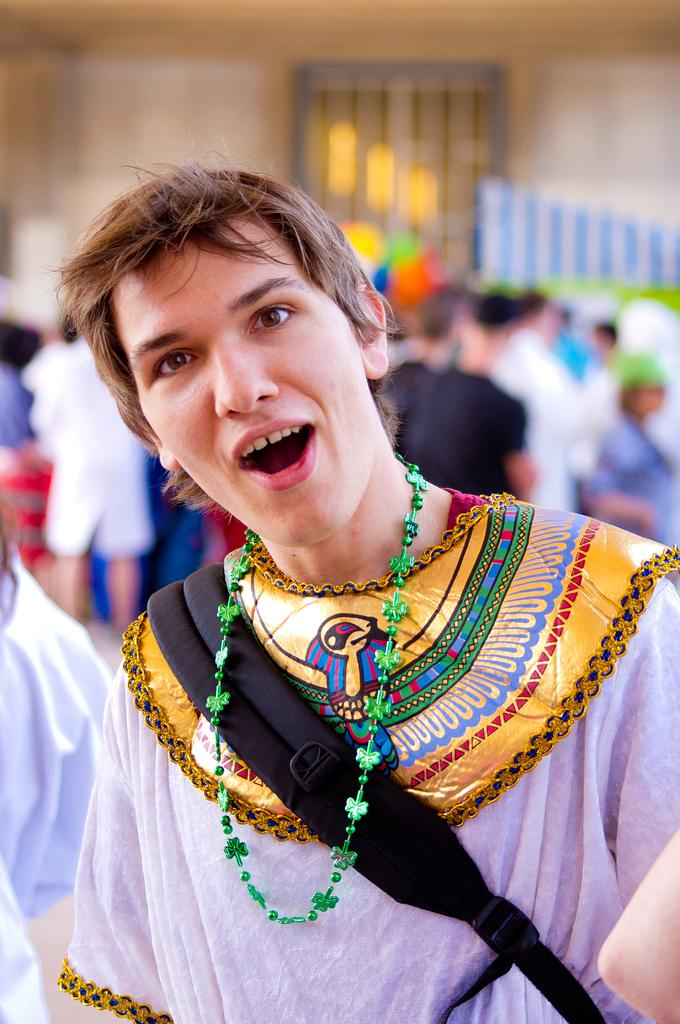What is the person in the image wearing on their body? The person is wearing a bag in the image. Are there any other people visible in the image? Yes, there are other people behind the person with the bag. What can be seen in the background of the image? There is a wall with a window in the background of the image. What type of lace can be seen on the person's finger in the image? There is no lace or finger visible on the person in the image. 